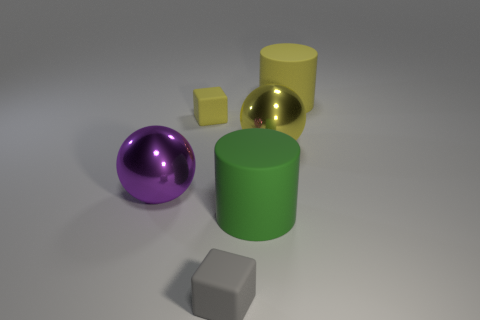What number of objects are either small matte blocks to the left of the small gray rubber object or rubber objects behind the tiny gray matte cube?
Provide a succinct answer. 3. Is the number of tiny rubber objects that are behind the gray object less than the number of green things?
Give a very brief answer. No. Is there a cylinder that has the same size as the green matte object?
Your answer should be very brief. Yes. Do the green matte object and the yellow cylinder have the same size?
Provide a succinct answer. Yes. How many things are cubes or big purple objects?
Offer a very short reply. 3. Is the number of purple metal objects in front of the green matte cylinder the same as the number of big shiny objects?
Your answer should be very brief. No. There is a large rubber object that is behind the big rubber cylinder in front of the big yellow cylinder; are there any small gray cubes behind it?
Make the answer very short. No. What is the color of the large object that is the same material as the yellow ball?
Offer a very short reply. Purple. What number of cylinders are either big matte objects or yellow things?
Keep it short and to the point. 2. What is the size of the matte block behind the matte cylinder that is in front of the small cube that is to the left of the small gray rubber thing?
Offer a very short reply. Small. 